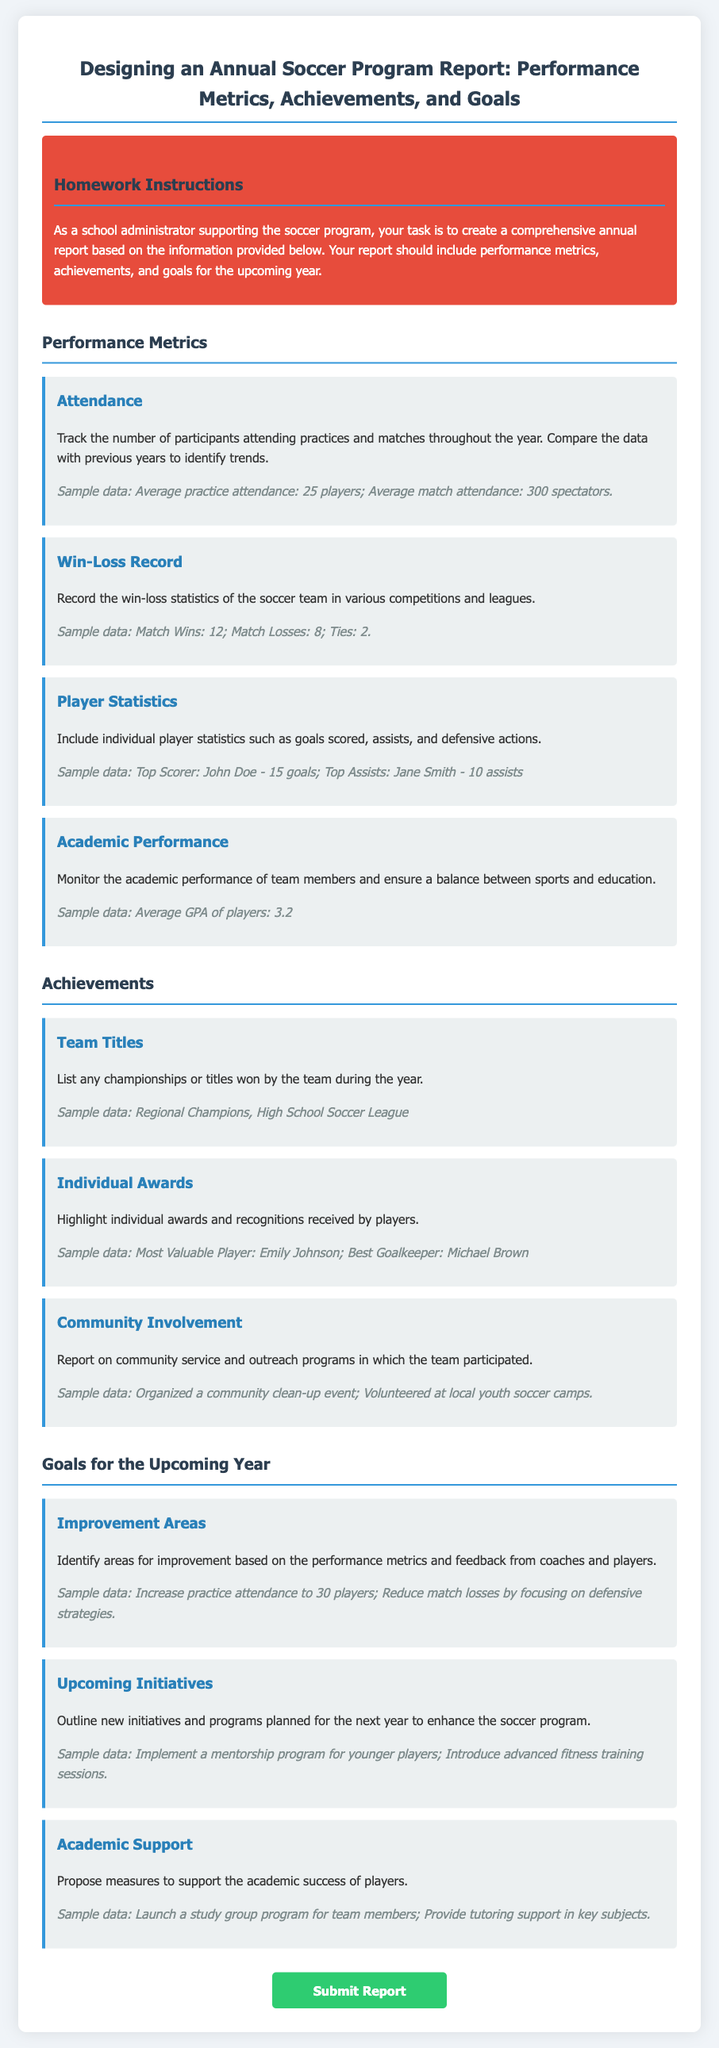What is the average practice attendance? The average practice attendance is mentioned in the performance metrics section of the document.
Answer: 25 players What title did the soccer team win? The document provides specific achievements including team titles in the achievements section.
Answer: Regional Champions Who was the top scorer for the team? The performance metrics section lists individual player statistics, including who scored the most goals.
Answer: John Doe What is the average GPA of players? The academic performance metric section refers to the academic performance of team members as average GPA.
Answer: 3.2 What is one area for improvement for the upcoming year? The goals for the upcoming year section identifies specific areas for improvement based on feedback received.
Answer: Increase practice attendance to 30 players How many match wins did the team achieve? The win-loss record in the performance metrics section includes the total number of match wins for the team.
Answer: 12 What type of community involvement did the team participate in? The document outlines the community involvement within the achievements section of the report.
Answer: Organized a community clean-up event What plan is proposed to support academic success? The goals section describes proposed initiatives aimed at enhancing players' academic achievements.
Answer: Launch a study group program for team members Who received the Most Valuable Player award? The individual awards section details special recognitions given to players for their performance.
Answer: Emily Johnson 